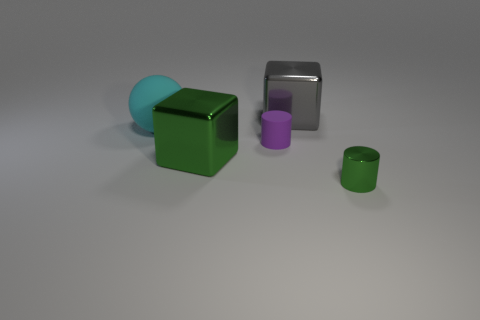Add 1 big cyan rubber spheres. How many objects exist? 6 Subtract all balls. How many objects are left? 4 Add 5 cyan rubber objects. How many cyan rubber objects are left? 6 Add 5 big yellow objects. How many big yellow objects exist? 5 Subtract 1 purple cylinders. How many objects are left? 4 Subtract all small green metallic cylinders. Subtract all red cubes. How many objects are left? 4 